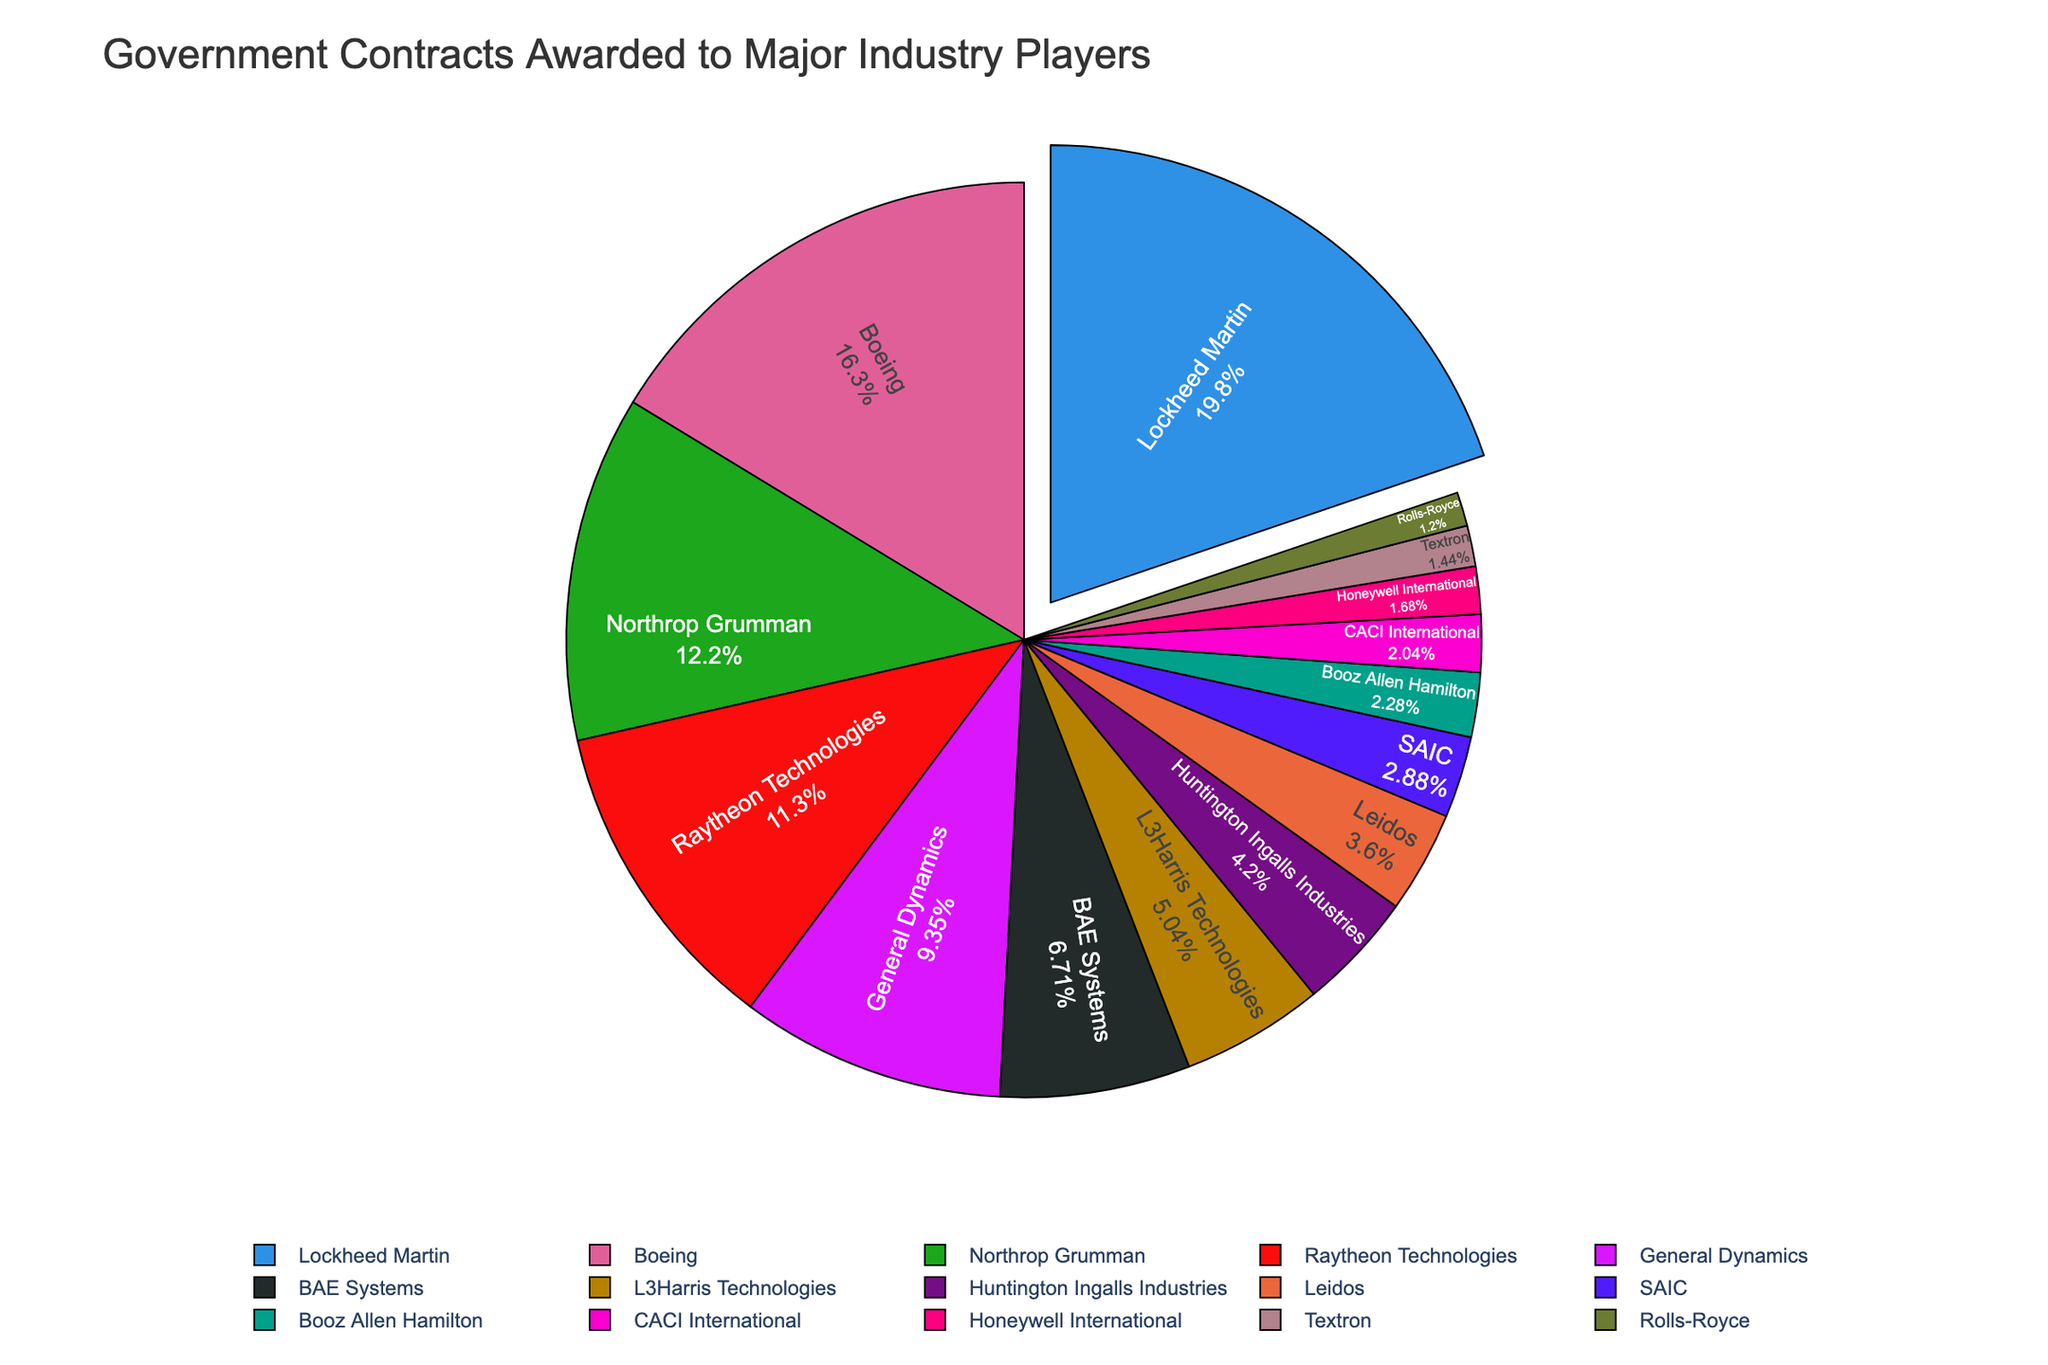Which company has the highest percentage of government contract value? Lockheed Martin's segment is pulled out and it's the largest in the pie chart, indicating the highest contract value. Lockheed Martin has the highest percentage.
Answer: Lockheed Martin What is the combined contract value percentage of the top three companies? Lockheed Martin, Boeing, and Northrop Grumman are the top three companies. Their individual percentages are visually the largest in the chart. Summing these percentages gives the combined value.
Answer: approximately 68.5% Which company has the lowest contract value, and where is it located on the chart? Rolls-Royce is the smallest segment on the pie chart, and thus has the lowest contract value. It is located at the smallest wedge of the pie chart.
Answer: Rolls-Royce How does Raytheon's contract value compare to General Dynamics'? Raytheon Technologies has a larger wedge than General Dynamics on the pie chart, indicating a higher contract value.
Answer: Raytheon Technologies has a higher value What is the approximate difference in contract value percentage between Lockheed Martin and Boeing? Lockheed Martin's percentage is the largest, and Boeing's is the second largest. Subtracting Boeing's percentage from Lockheed Martin's percentage gives the difference.
Answer: approximately 8% Which companies have a contract value percentage below 5%? The smallest wedges on the pie chart represent companies with values below 5%. These are Leidos, SAIC, Booz Allen Hamilton, CACI International, Honeywell International, Textron, and Rolls-Royce.
Answer: Leidos, SAIC, Booz Allen Hamilton, CACI International, Honeywell International, Textron, Rolls-Royce What is the visual difference between the contract value of L3Harris Technologies and Huntington Ingalls Industries? The size of the wedge for L3Harris Technologies is larger than that of Huntington Ingalls Industries, indicating a higher contract value.
Answer: L3Harris Technologies has a higher value Calculate the total percentage of contract values for companies with values above $5000 million. Companies with values above $5000 million are Lockheed Martin, Boeing, and Northrop Grumman. Adding their percentages gives the total.
Answer: approximately 68.5% Which companies have a contract value close to $2000 million and how are they located relative to each other on the chart? L3Harris Technologies and Huntington Ingalls Industries have values close to $2000 million. L3Harris Technologies has a slightly larger wedge and is placed right next to Huntington Ingalls Industries on the pie chart.
Answer: L3Harris Technologies, Huntington Ingalls Industries Which company is presented in the most contrasting color to Lockheed Martin, and what does it indicate about its contract value? Companies are color-coded uniquely. Next to Lockheed Martin, the segment with the starkest contrast often indicates a significant contract value but not as high. Boeing, represented in a different prominent color, has the second-highest contract value.
Answer: Boeing 